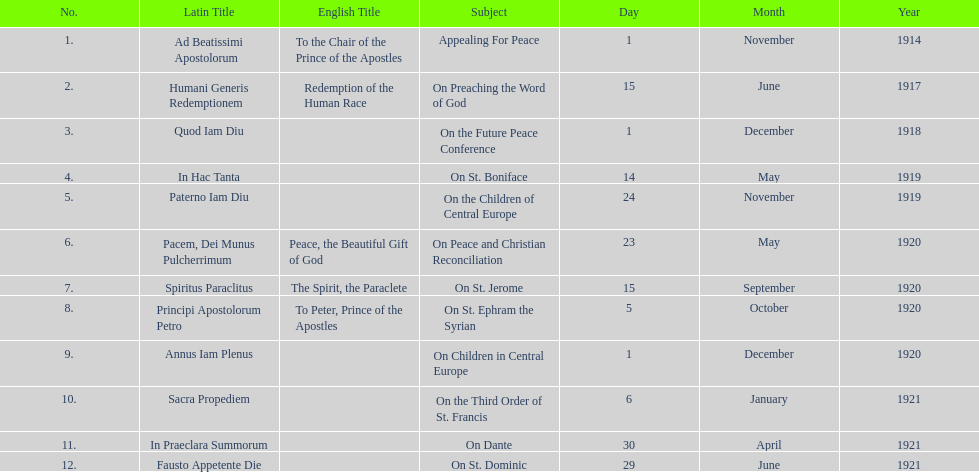What are the number of titles with a date of november? 2. 